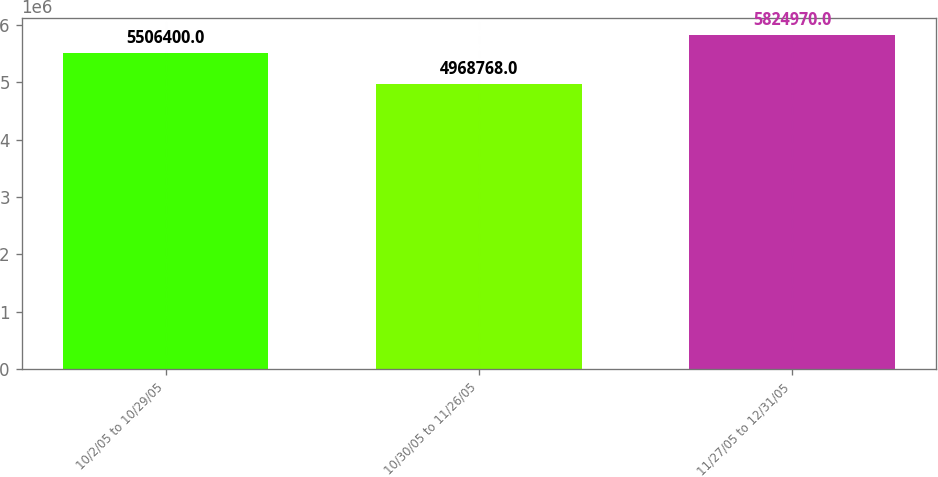Convert chart to OTSL. <chart><loc_0><loc_0><loc_500><loc_500><bar_chart><fcel>10/2/05 to 10/29/05<fcel>10/30/05 to 11/26/05<fcel>11/27/05 to 12/31/05<nl><fcel>5.5064e+06<fcel>4.96877e+06<fcel>5.82497e+06<nl></chart> 